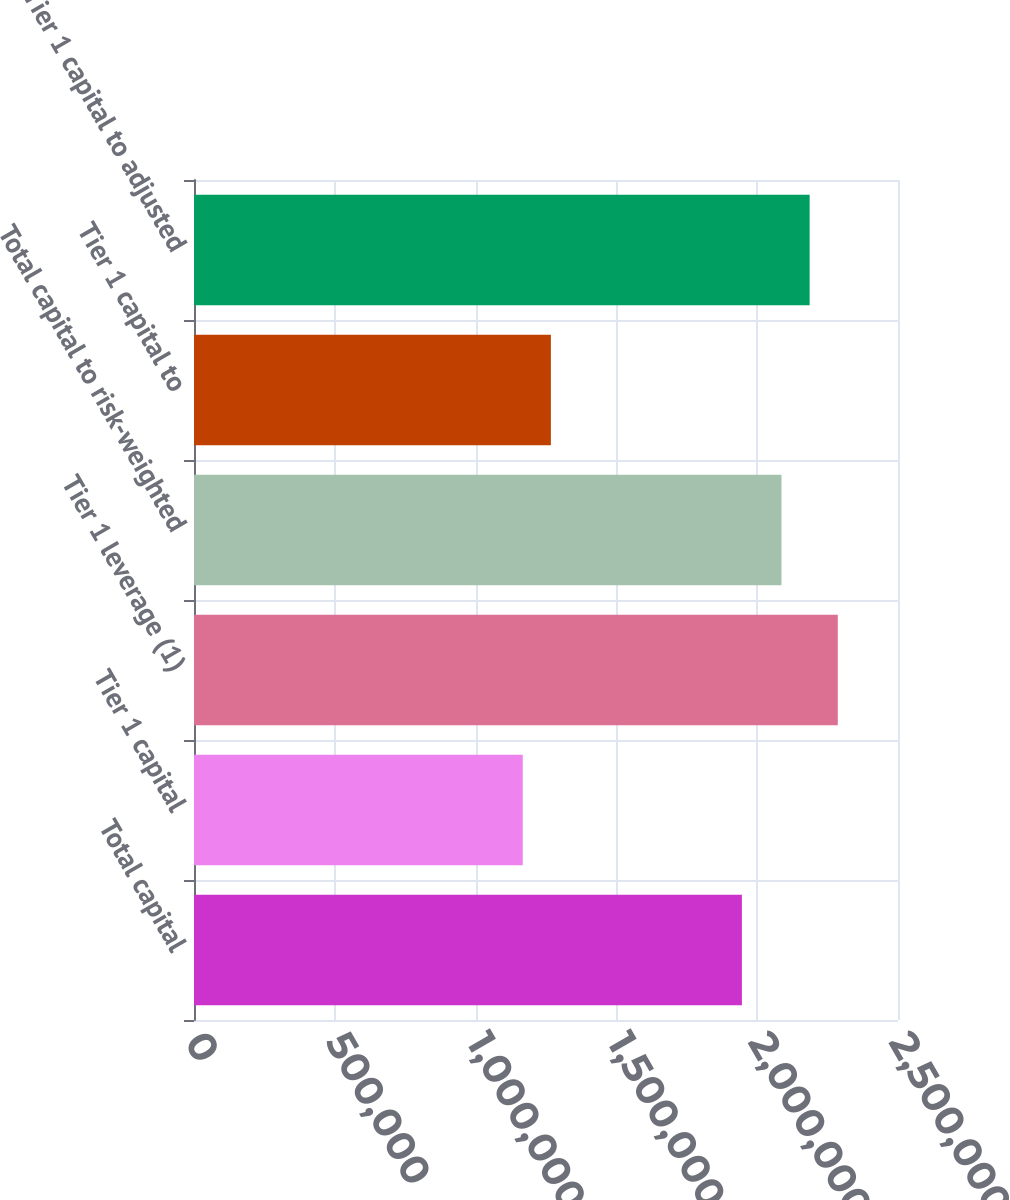Convert chart. <chart><loc_0><loc_0><loc_500><loc_500><bar_chart><fcel>Total capital<fcel>Tier 1 capital<fcel>Tier 1 leverage (1)<fcel>Total capital to risk-weighted<fcel>Tier 1 capital to<fcel>Tier 1 capital to adjusted<nl><fcel>1.94567e+06<fcel>1.1674e+06<fcel>2.28619e+06<fcel>2.08624e+06<fcel>1.26737e+06<fcel>2.18622e+06<nl></chart> 